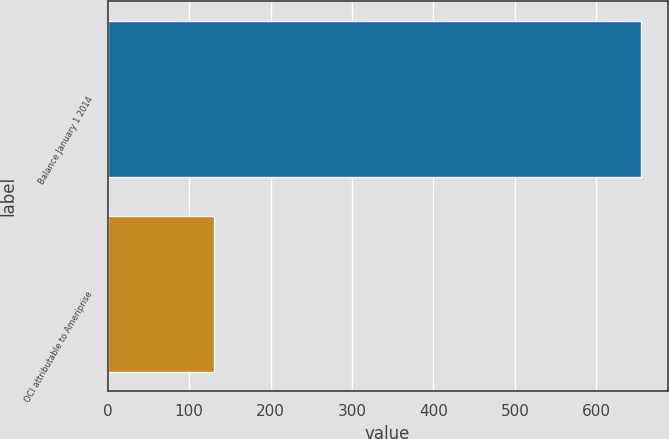<chart> <loc_0><loc_0><loc_500><loc_500><bar_chart><fcel>Balance January 1 2014<fcel>OCI attributable to Ameriprise<nl><fcel>655<fcel>131<nl></chart> 